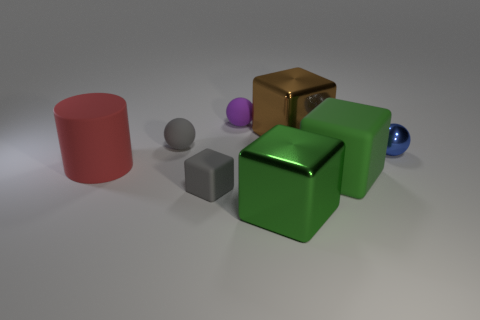Are there the same number of gray rubber cubes on the left side of the tiny matte block and large metallic things in front of the small metal object?
Provide a succinct answer. No. What material is the gray thing that is the same shape as the small purple thing?
Offer a terse response. Rubber. There is a big matte thing that is on the left side of the shiny object left of the large object behind the small metal object; what is its shape?
Your answer should be very brief. Cylinder. Are there more blue balls on the left side of the brown metallic cube than large brown matte blocks?
Your answer should be very brief. No. There is a big rubber thing on the right side of the tiny purple matte object; does it have the same shape as the large green metal object?
Make the answer very short. Yes. There is a tiny object that is in front of the large red matte cylinder; what material is it?
Offer a very short reply. Rubber. What number of shiny objects have the same shape as the small purple rubber object?
Offer a very short reply. 1. What is the small gray thing that is in front of the matte sphere on the left side of the purple matte ball made of?
Offer a very short reply. Rubber. What is the shape of the large shiny thing that is the same color as the big rubber cube?
Provide a succinct answer. Cube. Are there any large green objects made of the same material as the blue sphere?
Offer a terse response. Yes. 